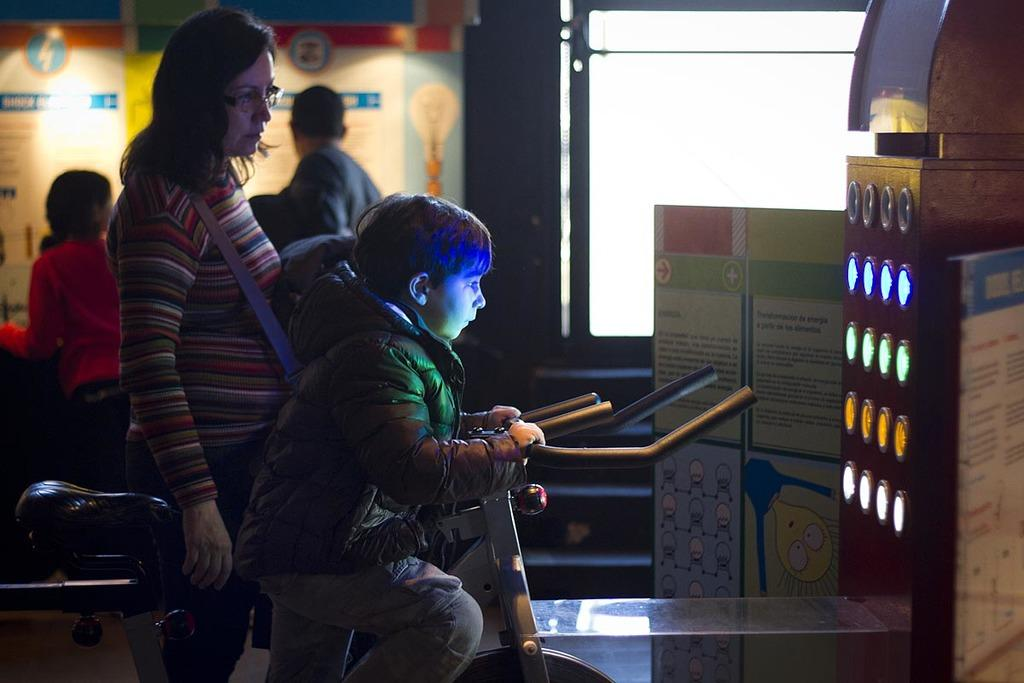What is the child holding in the image? The fact does not specify what the child is holding, so we cannot definitively answer this question. What is the woman wearing on her body? The woman is wearing a bag. What is located in front of the scene? There is a machine and a board in front of the scene. Are there any people visible in the image? Yes, there are people visible at the back side of the image. What architectural feature can be seen at the back side of the image? There is a window at the back side of the image. What type of noise is coming from the machine in the image? The fact does not mention any noise coming from the machine, so we cannot definitively answer this question. 